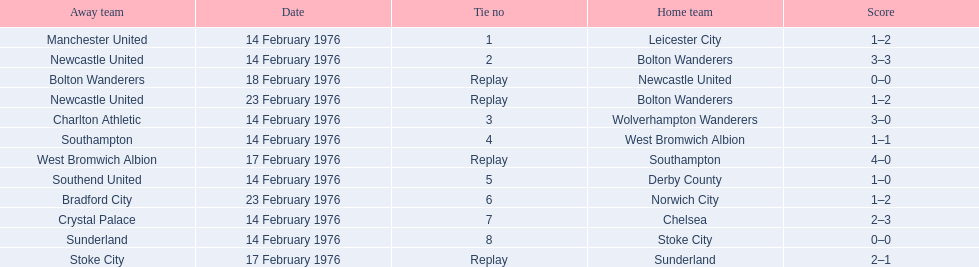Who was the home team in the game on the top of the table? Leicester City. 